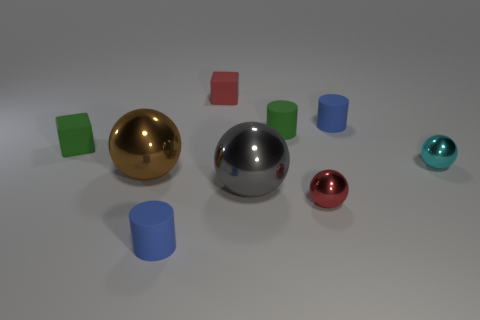There is a brown thing that is the same shape as the gray metal object; what is its material?
Keep it short and to the point. Metal. The object that is both behind the small cyan metallic ball and in front of the tiny green rubber cylinder is made of what material?
Make the answer very short. Rubber. How many other objects are there of the same material as the green cylinder?
Give a very brief answer. 4. What is the size of the sphere that is on the left side of the small matte cube that is behind the blue matte thing that is behind the brown shiny object?
Provide a short and direct response. Large. How many metallic things are either big gray cubes or small green cylinders?
Your response must be concise. 0. Do the red matte thing and the tiny green thing that is to the right of the green matte cube have the same shape?
Your answer should be very brief. No. Are there more blue cylinders that are behind the gray thing than matte cylinders behind the small cyan metal sphere?
Your answer should be very brief. No. Is there a matte cylinder that is behind the small green cube in front of the blue rubber cylinder that is behind the small green cube?
Give a very brief answer. Yes. Is the shape of the cyan shiny thing in front of the red matte thing the same as  the large brown metallic thing?
Provide a succinct answer. Yes. Is the number of cubes that are behind the green cube less than the number of things to the right of the brown sphere?
Keep it short and to the point. Yes. 